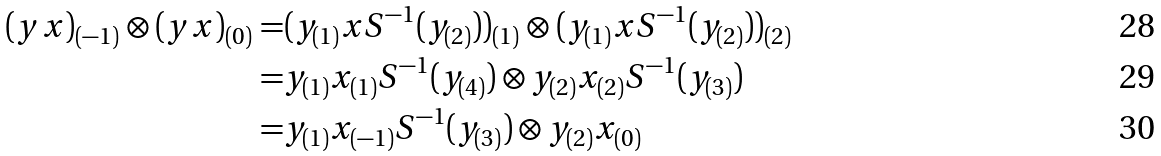Convert formula to latex. <formula><loc_0><loc_0><loc_500><loc_500>( y x ) _ { ( - 1 ) } \otimes ( y x ) _ { ( 0 ) } = & ( y _ { ( 1 ) } x S ^ { - 1 } ( y _ { ( 2 ) } ) ) _ { ( 1 ) } \otimes ( y _ { ( 1 ) } x S ^ { - 1 } ( y _ { ( 2 ) } ) ) _ { ( 2 ) } \\ = & y _ { ( 1 ) } x _ { ( 1 ) } S ^ { - 1 } ( y _ { ( 4 ) } ) \otimes y _ { ( 2 ) } x _ { ( 2 ) } S ^ { - 1 } ( y _ { ( 3 ) } ) \\ = & y _ { ( 1 ) } x _ { ( - 1 ) } S ^ { - 1 } ( y _ { ( 3 ) } ) \otimes y _ { ( 2 ) } x _ { ( 0 ) }</formula> 